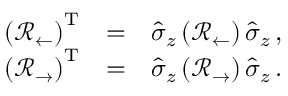<formula> <loc_0><loc_0><loc_500><loc_500>\begin{array} { r l r } { \left ( \mathcal { R } _ { \leftarrow } \right ) ^ { T } } & { = } & { \hat { \sigma } _ { z } \left ( \mathcal { R } _ { \leftarrow } \right ) \hat { \sigma } _ { z } \, , } \\ { \left ( \mathcal { R } _ { \rightarrow } \right ) ^ { T } } & { = } & { \hat { \sigma } _ { z } \left ( \mathcal { R } _ { \rightarrow } \right ) \hat { \sigma } _ { z } \, . } \end{array}</formula> 